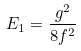Convert formula to latex. <formula><loc_0><loc_0><loc_500><loc_500>E _ { 1 } = \frac { g ^ { 2 } } { 8 f ^ { 2 } }</formula> 